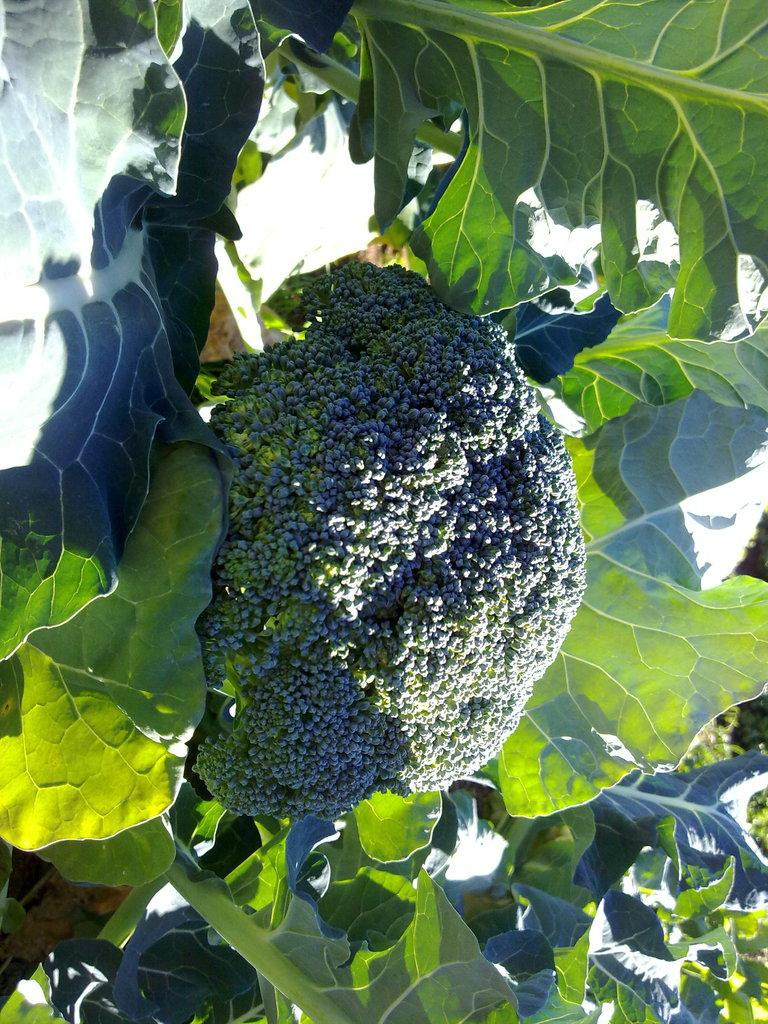What type of plant is visible in the image? There is a broccoli plant in the image. How many passengers are on the broccoli plant in the image? There are no passengers on the broccoli plant in the image, as it is a plant and not a mode of transportation. 